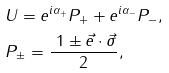Convert formula to latex. <formula><loc_0><loc_0><loc_500><loc_500>& U = e ^ { i \alpha _ { + } } P _ { + } + e ^ { i \alpha _ { - } } P _ { - } , \\ & P _ { \pm } = \frac { \ 1 \pm \vec { e } \cdot \vec { \sigma } } { 2 } ,</formula> 